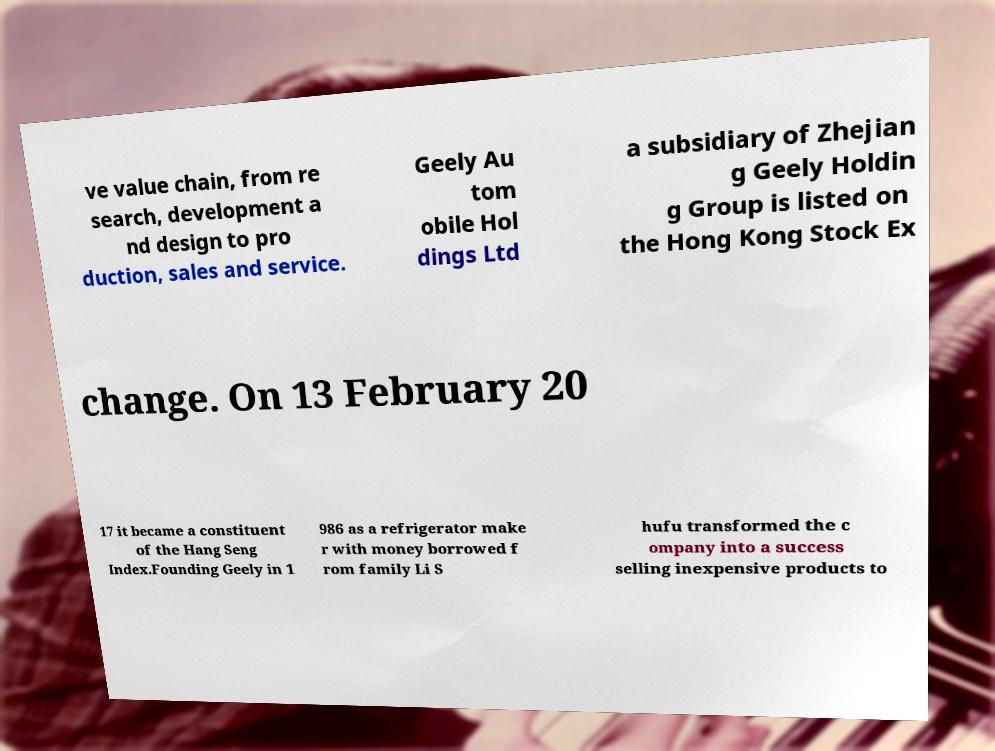Could you assist in decoding the text presented in this image and type it out clearly? ve value chain, from re search, development a nd design to pro duction, sales and service. Geely Au tom obile Hol dings Ltd a subsidiary of Zhejian g Geely Holdin g Group is listed on the Hong Kong Stock Ex change. On 13 February 20 17 it became a constituent of the Hang Seng Index.Founding Geely in 1 986 as a refrigerator make r with money borrowed f rom family Li S hufu transformed the c ompany into a success selling inexpensive products to 